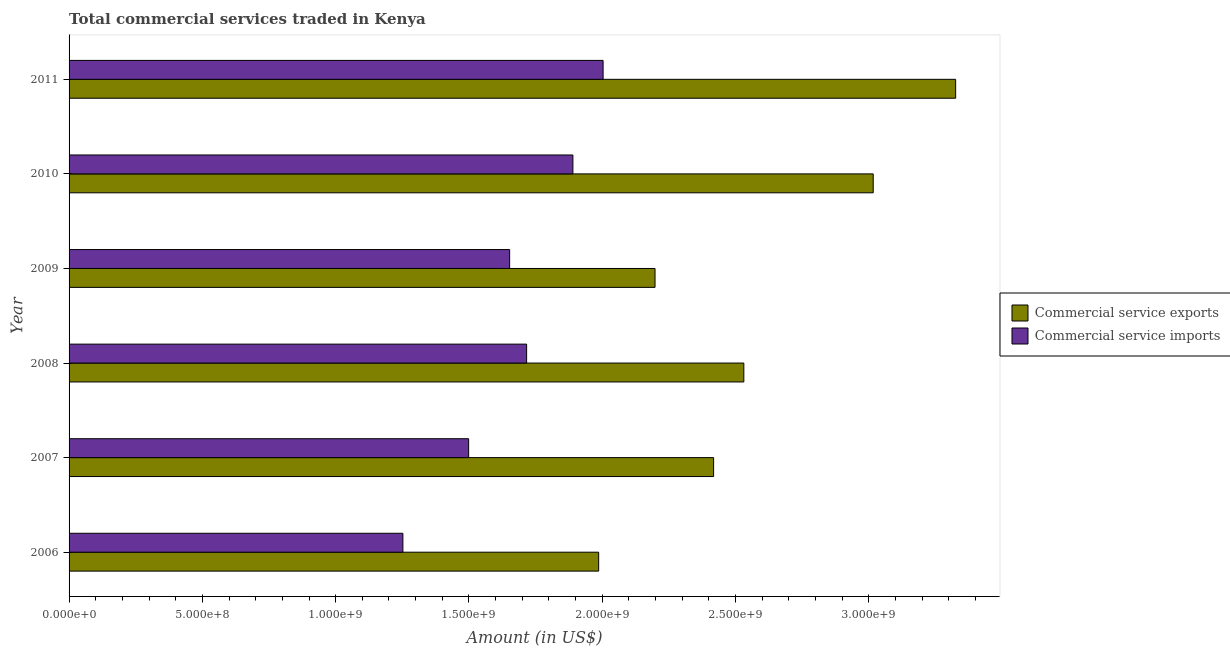How many different coloured bars are there?
Ensure brevity in your answer.  2. How many groups of bars are there?
Ensure brevity in your answer.  6. How many bars are there on the 5th tick from the top?
Your answer should be compact. 2. What is the label of the 1st group of bars from the top?
Make the answer very short. 2011. In how many cases, is the number of bars for a given year not equal to the number of legend labels?
Provide a succinct answer. 0. What is the amount of commercial service exports in 2009?
Provide a short and direct response. 2.20e+09. Across all years, what is the maximum amount of commercial service imports?
Keep it short and to the point. 2.00e+09. Across all years, what is the minimum amount of commercial service exports?
Ensure brevity in your answer.  1.99e+09. In which year was the amount of commercial service exports maximum?
Ensure brevity in your answer.  2011. In which year was the amount of commercial service imports minimum?
Your answer should be compact. 2006. What is the total amount of commercial service exports in the graph?
Your response must be concise. 1.55e+1. What is the difference between the amount of commercial service exports in 2007 and that in 2010?
Provide a short and direct response. -5.99e+08. What is the difference between the amount of commercial service imports in 2007 and the amount of commercial service exports in 2011?
Keep it short and to the point. -1.83e+09. What is the average amount of commercial service imports per year?
Provide a succinct answer. 1.67e+09. In the year 2010, what is the difference between the amount of commercial service imports and amount of commercial service exports?
Make the answer very short. -1.13e+09. What is the ratio of the amount of commercial service imports in 2009 to that in 2010?
Your response must be concise. 0.87. Is the difference between the amount of commercial service imports in 2007 and 2011 greater than the difference between the amount of commercial service exports in 2007 and 2011?
Give a very brief answer. Yes. What is the difference between the highest and the second highest amount of commercial service imports?
Provide a succinct answer. 1.13e+08. What is the difference between the highest and the lowest amount of commercial service exports?
Provide a succinct answer. 1.34e+09. What does the 1st bar from the top in 2006 represents?
Your answer should be very brief. Commercial service imports. What does the 1st bar from the bottom in 2010 represents?
Ensure brevity in your answer.  Commercial service exports. Are all the bars in the graph horizontal?
Keep it short and to the point. Yes. How many years are there in the graph?
Make the answer very short. 6. What is the difference between two consecutive major ticks on the X-axis?
Offer a very short reply. 5.00e+08. Does the graph contain any zero values?
Make the answer very short. No. Where does the legend appear in the graph?
Your answer should be compact. Center right. How many legend labels are there?
Provide a short and direct response. 2. How are the legend labels stacked?
Give a very brief answer. Vertical. What is the title of the graph?
Keep it short and to the point. Total commercial services traded in Kenya. What is the Amount (in US$) in Commercial service exports in 2006?
Ensure brevity in your answer.  1.99e+09. What is the Amount (in US$) in Commercial service imports in 2006?
Ensure brevity in your answer.  1.25e+09. What is the Amount (in US$) of Commercial service exports in 2007?
Offer a very short reply. 2.42e+09. What is the Amount (in US$) in Commercial service imports in 2007?
Your answer should be compact. 1.50e+09. What is the Amount (in US$) of Commercial service exports in 2008?
Offer a very short reply. 2.53e+09. What is the Amount (in US$) of Commercial service imports in 2008?
Ensure brevity in your answer.  1.72e+09. What is the Amount (in US$) of Commercial service exports in 2009?
Ensure brevity in your answer.  2.20e+09. What is the Amount (in US$) of Commercial service imports in 2009?
Make the answer very short. 1.65e+09. What is the Amount (in US$) in Commercial service exports in 2010?
Your answer should be compact. 3.02e+09. What is the Amount (in US$) of Commercial service imports in 2010?
Offer a terse response. 1.89e+09. What is the Amount (in US$) in Commercial service exports in 2011?
Your answer should be very brief. 3.33e+09. What is the Amount (in US$) in Commercial service imports in 2011?
Provide a succinct answer. 2.00e+09. Across all years, what is the maximum Amount (in US$) of Commercial service exports?
Your answer should be compact. 3.33e+09. Across all years, what is the maximum Amount (in US$) of Commercial service imports?
Offer a terse response. 2.00e+09. Across all years, what is the minimum Amount (in US$) in Commercial service exports?
Provide a succinct answer. 1.99e+09. Across all years, what is the minimum Amount (in US$) of Commercial service imports?
Offer a terse response. 1.25e+09. What is the total Amount (in US$) of Commercial service exports in the graph?
Ensure brevity in your answer.  1.55e+1. What is the total Amount (in US$) of Commercial service imports in the graph?
Your answer should be compact. 1.00e+1. What is the difference between the Amount (in US$) of Commercial service exports in 2006 and that in 2007?
Ensure brevity in your answer.  -4.31e+08. What is the difference between the Amount (in US$) in Commercial service imports in 2006 and that in 2007?
Your answer should be very brief. -2.47e+08. What is the difference between the Amount (in US$) of Commercial service exports in 2006 and that in 2008?
Your response must be concise. -5.44e+08. What is the difference between the Amount (in US$) in Commercial service imports in 2006 and that in 2008?
Provide a short and direct response. -4.64e+08. What is the difference between the Amount (in US$) of Commercial service exports in 2006 and that in 2009?
Provide a short and direct response. -2.11e+08. What is the difference between the Amount (in US$) of Commercial service imports in 2006 and that in 2009?
Offer a terse response. -4.00e+08. What is the difference between the Amount (in US$) of Commercial service exports in 2006 and that in 2010?
Ensure brevity in your answer.  -1.03e+09. What is the difference between the Amount (in US$) of Commercial service imports in 2006 and that in 2010?
Your answer should be compact. -6.38e+08. What is the difference between the Amount (in US$) in Commercial service exports in 2006 and that in 2011?
Your answer should be compact. -1.34e+09. What is the difference between the Amount (in US$) in Commercial service imports in 2006 and that in 2011?
Ensure brevity in your answer.  -7.51e+08. What is the difference between the Amount (in US$) of Commercial service exports in 2007 and that in 2008?
Keep it short and to the point. -1.13e+08. What is the difference between the Amount (in US$) in Commercial service imports in 2007 and that in 2008?
Keep it short and to the point. -2.18e+08. What is the difference between the Amount (in US$) of Commercial service exports in 2007 and that in 2009?
Keep it short and to the point. 2.20e+08. What is the difference between the Amount (in US$) of Commercial service imports in 2007 and that in 2009?
Your answer should be compact. -1.54e+08. What is the difference between the Amount (in US$) in Commercial service exports in 2007 and that in 2010?
Ensure brevity in your answer.  -5.99e+08. What is the difference between the Amount (in US$) of Commercial service imports in 2007 and that in 2010?
Make the answer very short. -3.91e+08. What is the difference between the Amount (in US$) in Commercial service exports in 2007 and that in 2011?
Provide a succinct answer. -9.08e+08. What is the difference between the Amount (in US$) in Commercial service imports in 2007 and that in 2011?
Offer a very short reply. -5.04e+08. What is the difference between the Amount (in US$) of Commercial service exports in 2008 and that in 2009?
Give a very brief answer. 3.33e+08. What is the difference between the Amount (in US$) of Commercial service imports in 2008 and that in 2009?
Offer a terse response. 6.37e+07. What is the difference between the Amount (in US$) in Commercial service exports in 2008 and that in 2010?
Your response must be concise. -4.85e+08. What is the difference between the Amount (in US$) of Commercial service imports in 2008 and that in 2010?
Offer a very short reply. -1.74e+08. What is the difference between the Amount (in US$) in Commercial service exports in 2008 and that in 2011?
Make the answer very short. -7.95e+08. What is the difference between the Amount (in US$) in Commercial service imports in 2008 and that in 2011?
Make the answer very short. -2.87e+08. What is the difference between the Amount (in US$) of Commercial service exports in 2009 and that in 2010?
Provide a short and direct response. -8.18e+08. What is the difference between the Amount (in US$) of Commercial service imports in 2009 and that in 2010?
Provide a succinct answer. -2.37e+08. What is the difference between the Amount (in US$) in Commercial service exports in 2009 and that in 2011?
Offer a very short reply. -1.13e+09. What is the difference between the Amount (in US$) of Commercial service imports in 2009 and that in 2011?
Provide a short and direct response. -3.51e+08. What is the difference between the Amount (in US$) in Commercial service exports in 2010 and that in 2011?
Make the answer very short. -3.09e+08. What is the difference between the Amount (in US$) in Commercial service imports in 2010 and that in 2011?
Ensure brevity in your answer.  -1.13e+08. What is the difference between the Amount (in US$) in Commercial service exports in 2006 and the Amount (in US$) in Commercial service imports in 2007?
Give a very brief answer. 4.88e+08. What is the difference between the Amount (in US$) in Commercial service exports in 2006 and the Amount (in US$) in Commercial service imports in 2008?
Keep it short and to the point. 2.70e+08. What is the difference between the Amount (in US$) of Commercial service exports in 2006 and the Amount (in US$) of Commercial service imports in 2009?
Offer a very short reply. 3.34e+08. What is the difference between the Amount (in US$) in Commercial service exports in 2006 and the Amount (in US$) in Commercial service imports in 2010?
Offer a terse response. 9.67e+07. What is the difference between the Amount (in US$) in Commercial service exports in 2006 and the Amount (in US$) in Commercial service imports in 2011?
Your response must be concise. -1.66e+07. What is the difference between the Amount (in US$) of Commercial service exports in 2007 and the Amount (in US$) of Commercial service imports in 2008?
Provide a short and direct response. 7.01e+08. What is the difference between the Amount (in US$) in Commercial service exports in 2007 and the Amount (in US$) in Commercial service imports in 2009?
Provide a short and direct response. 7.65e+08. What is the difference between the Amount (in US$) in Commercial service exports in 2007 and the Amount (in US$) in Commercial service imports in 2010?
Provide a short and direct response. 5.28e+08. What is the difference between the Amount (in US$) of Commercial service exports in 2007 and the Amount (in US$) of Commercial service imports in 2011?
Give a very brief answer. 4.15e+08. What is the difference between the Amount (in US$) in Commercial service exports in 2008 and the Amount (in US$) in Commercial service imports in 2009?
Offer a very short reply. 8.78e+08. What is the difference between the Amount (in US$) in Commercial service exports in 2008 and the Amount (in US$) in Commercial service imports in 2010?
Offer a terse response. 6.41e+08. What is the difference between the Amount (in US$) in Commercial service exports in 2008 and the Amount (in US$) in Commercial service imports in 2011?
Your response must be concise. 5.28e+08. What is the difference between the Amount (in US$) of Commercial service exports in 2009 and the Amount (in US$) of Commercial service imports in 2010?
Keep it short and to the point. 3.08e+08. What is the difference between the Amount (in US$) of Commercial service exports in 2009 and the Amount (in US$) of Commercial service imports in 2011?
Your response must be concise. 1.95e+08. What is the difference between the Amount (in US$) in Commercial service exports in 2010 and the Amount (in US$) in Commercial service imports in 2011?
Ensure brevity in your answer.  1.01e+09. What is the average Amount (in US$) of Commercial service exports per year?
Keep it short and to the point. 2.58e+09. What is the average Amount (in US$) of Commercial service imports per year?
Ensure brevity in your answer.  1.67e+09. In the year 2006, what is the difference between the Amount (in US$) of Commercial service exports and Amount (in US$) of Commercial service imports?
Offer a terse response. 7.34e+08. In the year 2007, what is the difference between the Amount (in US$) of Commercial service exports and Amount (in US$) of Commercial service imports?
Your response must be concise. 9.19e+08. In the year 2008, what is the difference between the Amount (in US$) in Commercial service exports and Amount (in US$) in Commercial service imports?
Your response must be concise. 8.15e+08. In the year 2009, what is the difference between the Amount (in US$) in Commercial service exports and Amount (in US$) in Commercial service imports?
Your answer should be very brief. 5.45e+08. In the year 2010, what is the difference between the Amount (in US$) in Commercial service exports and Amount (in US$) in Commercial service imports?
Keep it short and to the point. 1.13e+09. In the year 2011, what is the difference between the Amount (in US$) of Commercial service exports and Amount (in US$) of Commercial service imports?
Make the answer very short. 1.32e+09. What is the ratio of the Amount (in US$) in Commercial service exports in 2006 to that in 2007?
Offer a very short reply. 0.82. What is the ratio of the Amount (in US$) of Commercial service imports in 2006 to that in 2007?
Provide a succinct answer. 0.84. What is the ratio of the Amount (in US$) in Commercial service exports in 2006 to that in 2008?
Your answer should be very brief. 0.78. What is the ratio of the Amount (in US$) of Commercial service imports in 2006 to that in 2008?
Your response must be concise. 0.73. What is the ratio of the Amount (in US$) in Commercial service exports in 2006 to that in 2009?
Provide a short and direct response. 0.9. What is the ratio of the Amount (in US$) in Commercial service imports in 2006 to that in 2009?
Your answer should be very brief. 0.76. What is the ratio of the Amount (in US$) in Commercial service exports in 2006 to that in 2010?
Ensure brevity in your answer.  0.66. What is the ratio of the Amount (in US$) in Commercial service imports in 2006 to that in 2010?
Your answer should be very brief. 0.66. What is the ratio of the Amount (in US$) in Commercial service exports in 2006 to that in 2011?
Provide a succinct answer. 0.6. What is the ratio of the Amount (in US$) of Commercial service imports in 2006 to that in 2011?
Provide a succinct answer. 0.63. What is the ratio of the Amount (in US$) of Commercial service exports in 2007 to that in 2008?
Keep it short and to the point. 0.96. What is the ratio of the Amount (in US$) of Commercial service imports in 2007 to that in 2008?
Your answer should be very brief. 0.87. What is the ratio of the Amount (in US$) of Commercial service imports in 2007 to that in 2009?
Your answer should be compact. 0.91. What is the ratio of the Amount (in US$) of Commercial service exports in 2007 to that in 2010?
Your answer should be compact. 0.8. What is the ratio of the Amount (in US$) in Commercial service imports in 2007 to that in 2010?
Ensure brevity in your answer.  0.79. What is the ratio of the Amount (in US$) of Commercial service exports in 2007 to that in 2011?
Your answer should be very brief. 0.73. What is the ratio of the Amount (in US$) in Commercial service imports in 2007 to that in 2011?
Your answer should be very brief. 0.75. What is the ratio of the Amount (in US$) of Commercial service exports in 2008 to that in 2009?
Offer a very short reply. 1.15. What is the ratio of the Amount (in US$) in Commercial service imports in 2008 to that in 2009?
Your response must be concise. 1.04. What is the ratio of the Amount (in US$) of Commercial service exports in 2008 to that in 2010?
Your answer should be compact. 0.84. What is the ratio of the Amount (in US$) in Commercial service imports in 2008 to that in 2010?
Offer a terse response. 0.91. What is the ratio of the Amount (in US$) of Commercial service exports in 2008 to that in 2011?
Make the answer very short. 0.76. What is the ratio of the Amount (in US$) in Commercial service imports in 2008 to that in 2011?
Provide a short and direct response. 0.86. What is the ratio of the Amount (in US$) of Commercial service exports in 2009 to that in 2010?
Your answer should be compact. 0.73. What is the ratio of the Amount (in US$) of Commercial service imports in 2009 to that in 2010?
Your answer should be compact. 0.87. What is the ratio of the Amount (in US$) of Commercial service exports in 2009 to that in 2011?
Provide a short and direct response. 0.66. What is the ratio of the Amount (in US$) in Commercial service imports in 2009 to that in 2011?
Keep it short and to the point. 0.82. What is the ratio of the Amount (in US$) in Commercial service exports in 2010 to that in 2011?
Your answer should be compact. 0.91. What is the ratio of the Amount (in US$) in Commercial service imports in 2010 to that in 2011?
Provide a succinct answer. 0.94. What is the difference between the highest and the second highest Amount (in US$) in Commercial service exports?
Ensure brevity in your answer.  3.09e+08. What is the difference between the highest and the second highest Amount (in US$) of Commercial service imports?
Give a very brief answer. 1.13e+08. What is the difference between the highest and the lowest Amount (in US$) of Commercial service exports?
Give a very brief answer. 1.34e+09. What is the difference between the highest and the lowest Amount (in US$) in Commercial service imports?
Offer a terse response. 7.51e+08. 